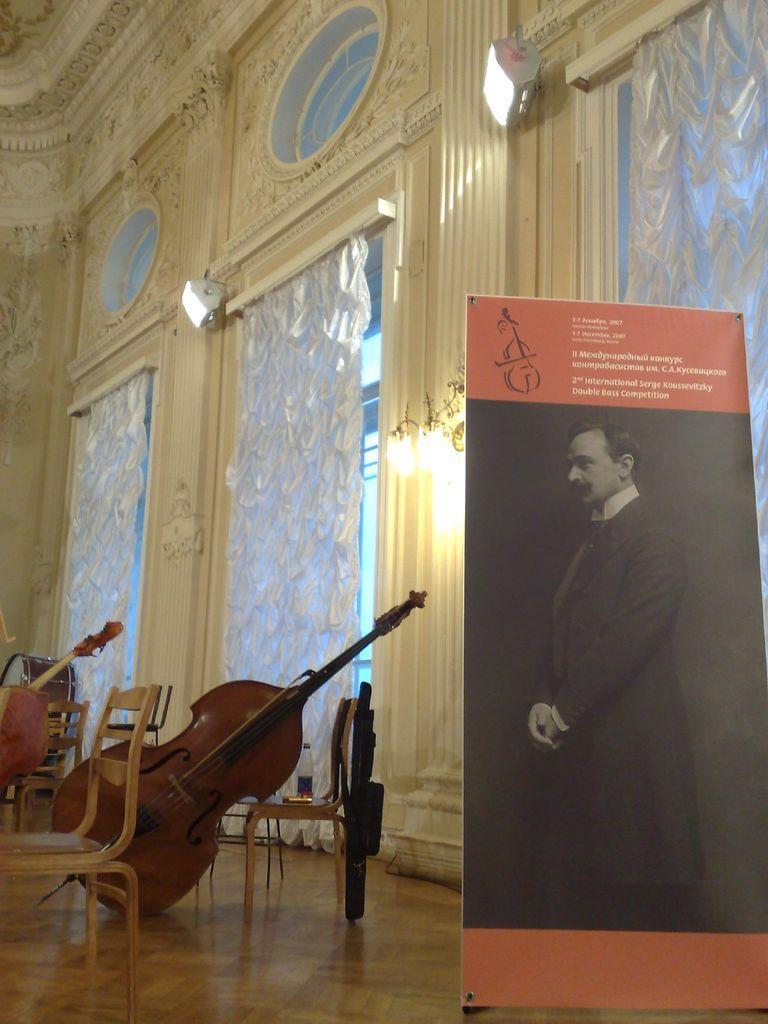Please provide a concise description of this image. A flex board is placed beside few musical instruments on chairs. 